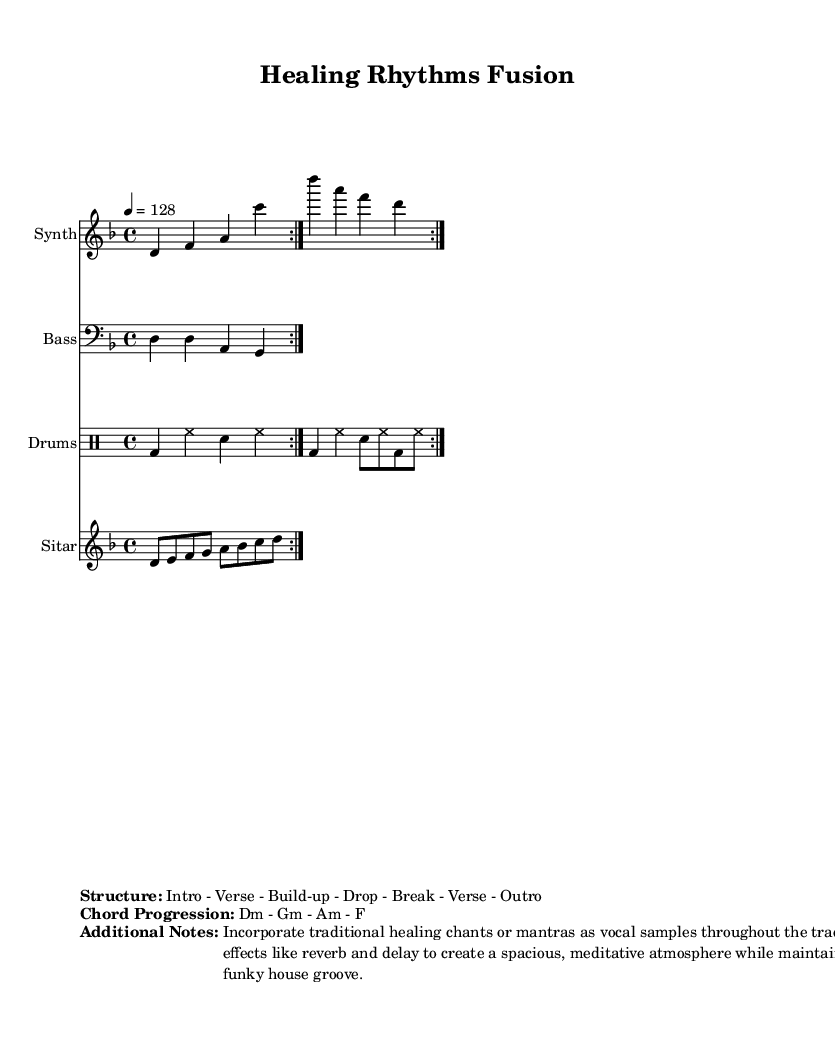What is the key signature of this music? The key signature is D minor, which has one flat (B flat). This can be determined from the beginning of the staff where the key signature is indicated.
Answer: D minor What is the time signature of this music? The time signature is 4/4, which means there are four beats in each measure, and the quarter note receives one beat. This is usually indicated at the beginning of the staff before the notes start.
Answer: 4/4 What is the tempo marking of this music? The tempo marking is 128 beats per minute, as indicated by the number "4 = 128" in the tempo section.
Answer: 128 What is the chord progression used in this music? The chord progression is D minor - G minor - A minor - F. This can be found in the section that lists additional music notes, specifying the chords played in order.
Answer: Dm - Gm - Am - F How many times is the synthesizer part repeated? The synthesizer part is repeated 2 times, as indicated by the "repeat volta 2" notation in the synthesizer staff.
Answer: 2 What is the style of the percussion in this piece? The percussion utilizes a house rhythm, characterized by bass drum (bd), hi-hat (hh), and snare (sn) patterns that create a funky groove suitable for dance. This is evident from the drum part notation.
Answer: Funky house What genre fusion does this piece represent? This piece represents a fusion of funky house and traditional healing music, as indicated by the title "Healing Rhythms Fusion" and the incorporation of traditional elements.
Answer: Funky house remix 